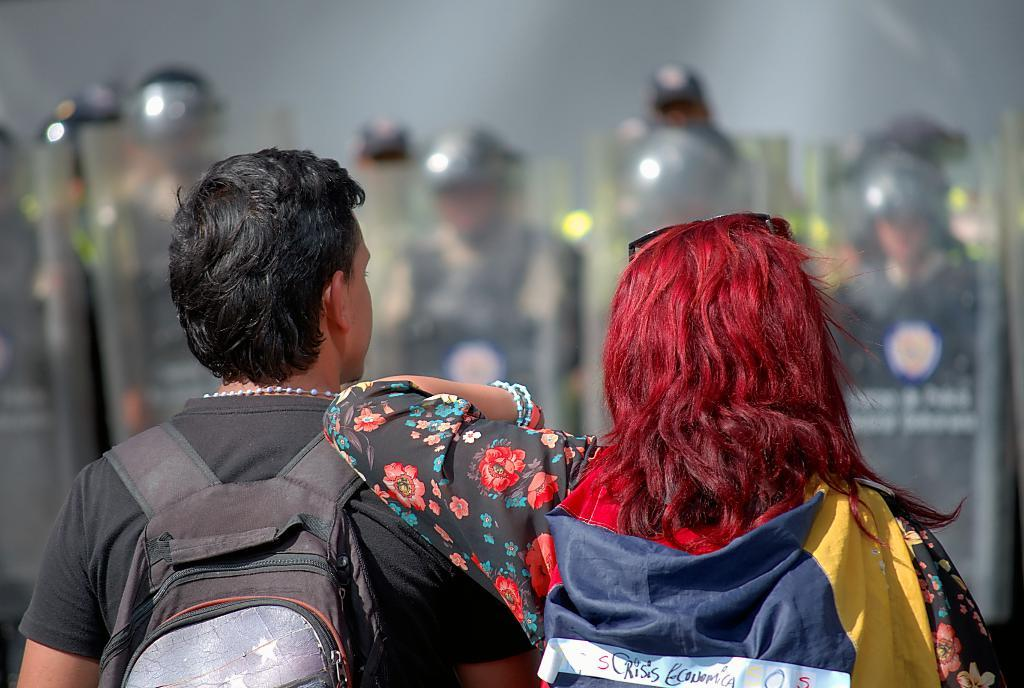What is the main subject of the image? The main subject of the image is a group of people. Can you describe the man on the left side of the image? The man on the left side of the image is carrying a bag. What can be seen in the background of the image? There are people holding riot shields in the background of the image. What type of umbrella is the man using to protect himself from the bee in the image? There is no umbrella or bee present in the image. Can you tell me the name of the man's daughter who is standing next to him in the image? There is no daughter present in the image. 